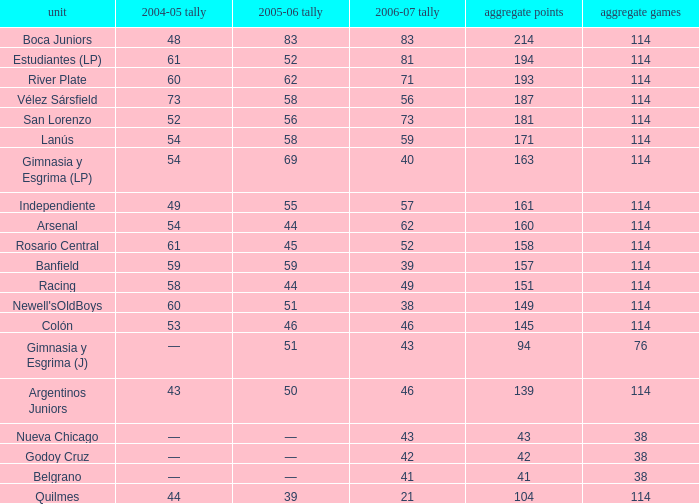Would you mind parsing the complete table? {'header': ['unit', '2004-05 tally', '2005-06 tally', '2006-07 tally', 'aggregate points', 'aggregate games'], 'rows': [['Boca Juniors', '48', '83', '83', '214', '114'], ['Estudiantes (LP)', '61', '52', '81', '194', '114'], ['River Plate', '60', '62', '71', '193', '114'], ['Vélez Sársfield', '73', '58', '56', '187', '114'], ['San Lorenzo', '52', '56', '73', '181', '114'], ['Lanús', '54', '58', '59', '171', '114'], ['Gimnasia y Esgrima (LP)', '54', '69', '40', '163', '114'], ['Independiente', '49', '55', '57', '161', '114'], ['Arsenal', '54', '44', '62', '160', '114'], ['Rosario Central', '61', '45', '52', '158', '114'], ['Banfield', '59', '59', '39', '157', '114'], ['Racing', '58', '44', '49', '151', '114'], ["Newell'sOldBoys", '60', '51', '38', '149', '114'], ['Colón', '53', '46', '46', '145', '114'], ['Gimnasia y Esgrima (J)', '—', '51', '43', '94', '76'], ['Argentinos Juniors', '43', '50', '46', '139', '114'], ['Nueva Chicago', '—', '—', '43', '43', '38'], ['Godoy Cruz', '—', '—', '42', '42', '38'], ['Belgrano', '—', '—', '41', '41', '38'], ['Quilmes', '44', '39', '21', '104', '114']]} What is the total pld with 158 points in 2006-07, and less than 52 points in 2006-07? None. 